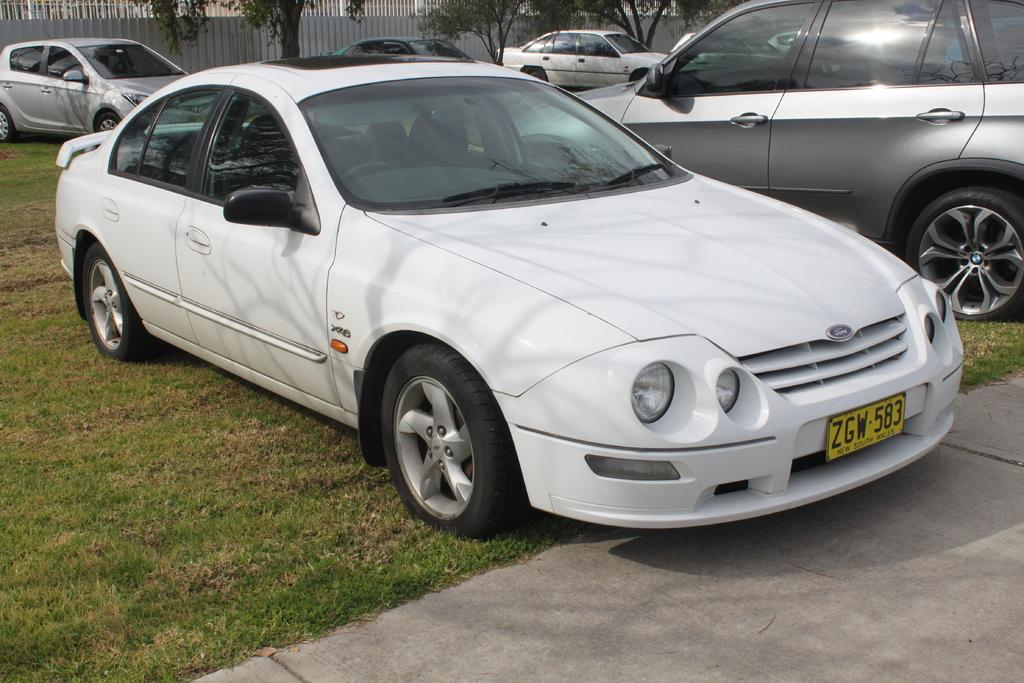What is the unusual location for the cars in the image? The cars are parked on the grass in the image. What can be seen in the background of the image? There is a metal fencing and trees in the background of the image. What type of scissors can be seen cutting the grass in the image? There are no scissors present in the image; the cars are parked on the grass. How does the tiger stretch in the image? There is no tiger present in the image. 